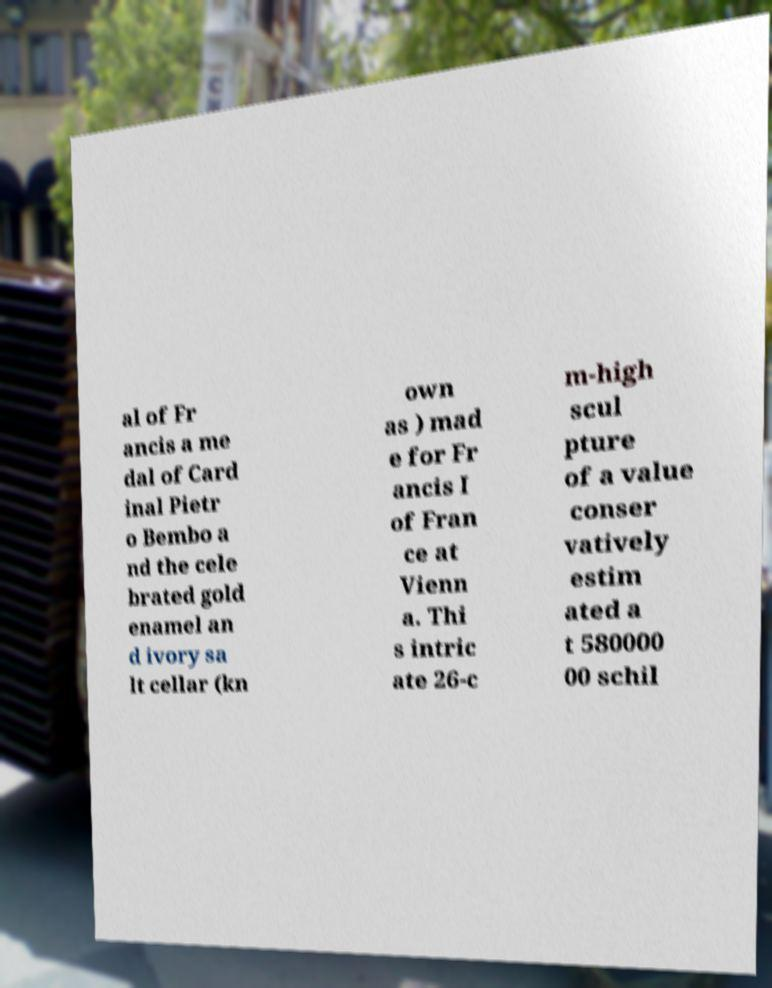What messages or text are displayed in this image? I need them in a readable, typed format. al of Fr ancis a me dal of Card inal Pietr o Bembo a nd the cele brated gold enamel an d ivory sa lt cellar (kn own as ) mad e for Fr ancis I of Fran ce at Vienn a. Thi s intric ate 26-c m-high scul pture of a value conser vatively estim ated a t 580000 00 schil 